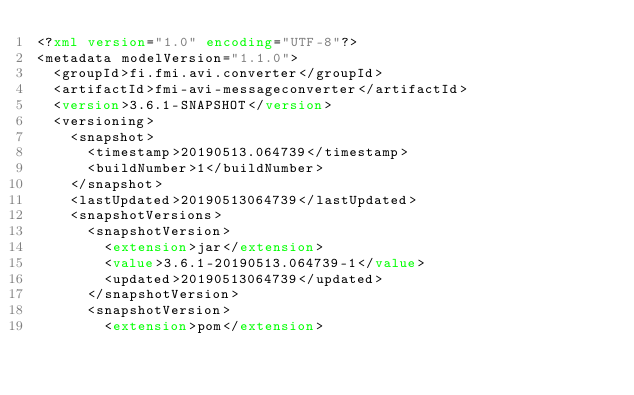<code> <loc_0><loc_0><loc_500><loc_500><_XML_><?xml version="1.0" encoding="UTF-8"?>
<metadata modelVersion="1.1.0">
  <groupId>fi.fmi.avi.converter</groupId>
  <artifactId>fmi-avi-messageconverter</artifactId>
  <version>3.6.1-SNAPSHOT</version>
  <versioning>
    <snapshot>
      <timestamp>20190513.064739</timestamp>
      <buildNumber>1</buildNumber>
    </snapshot>
    <lastUpdated>20190513064739</lastUpdated>
    <snapshotVersions>
      <snapshotVersion>
        <extension>jar</extension>
        <value>3.6.1-20190513.064739-1</value>
        <updated>20190513064739</updated>
      </snapshotVersion>
      <snapshotVersion>
        <extension>pom</extension></code> 